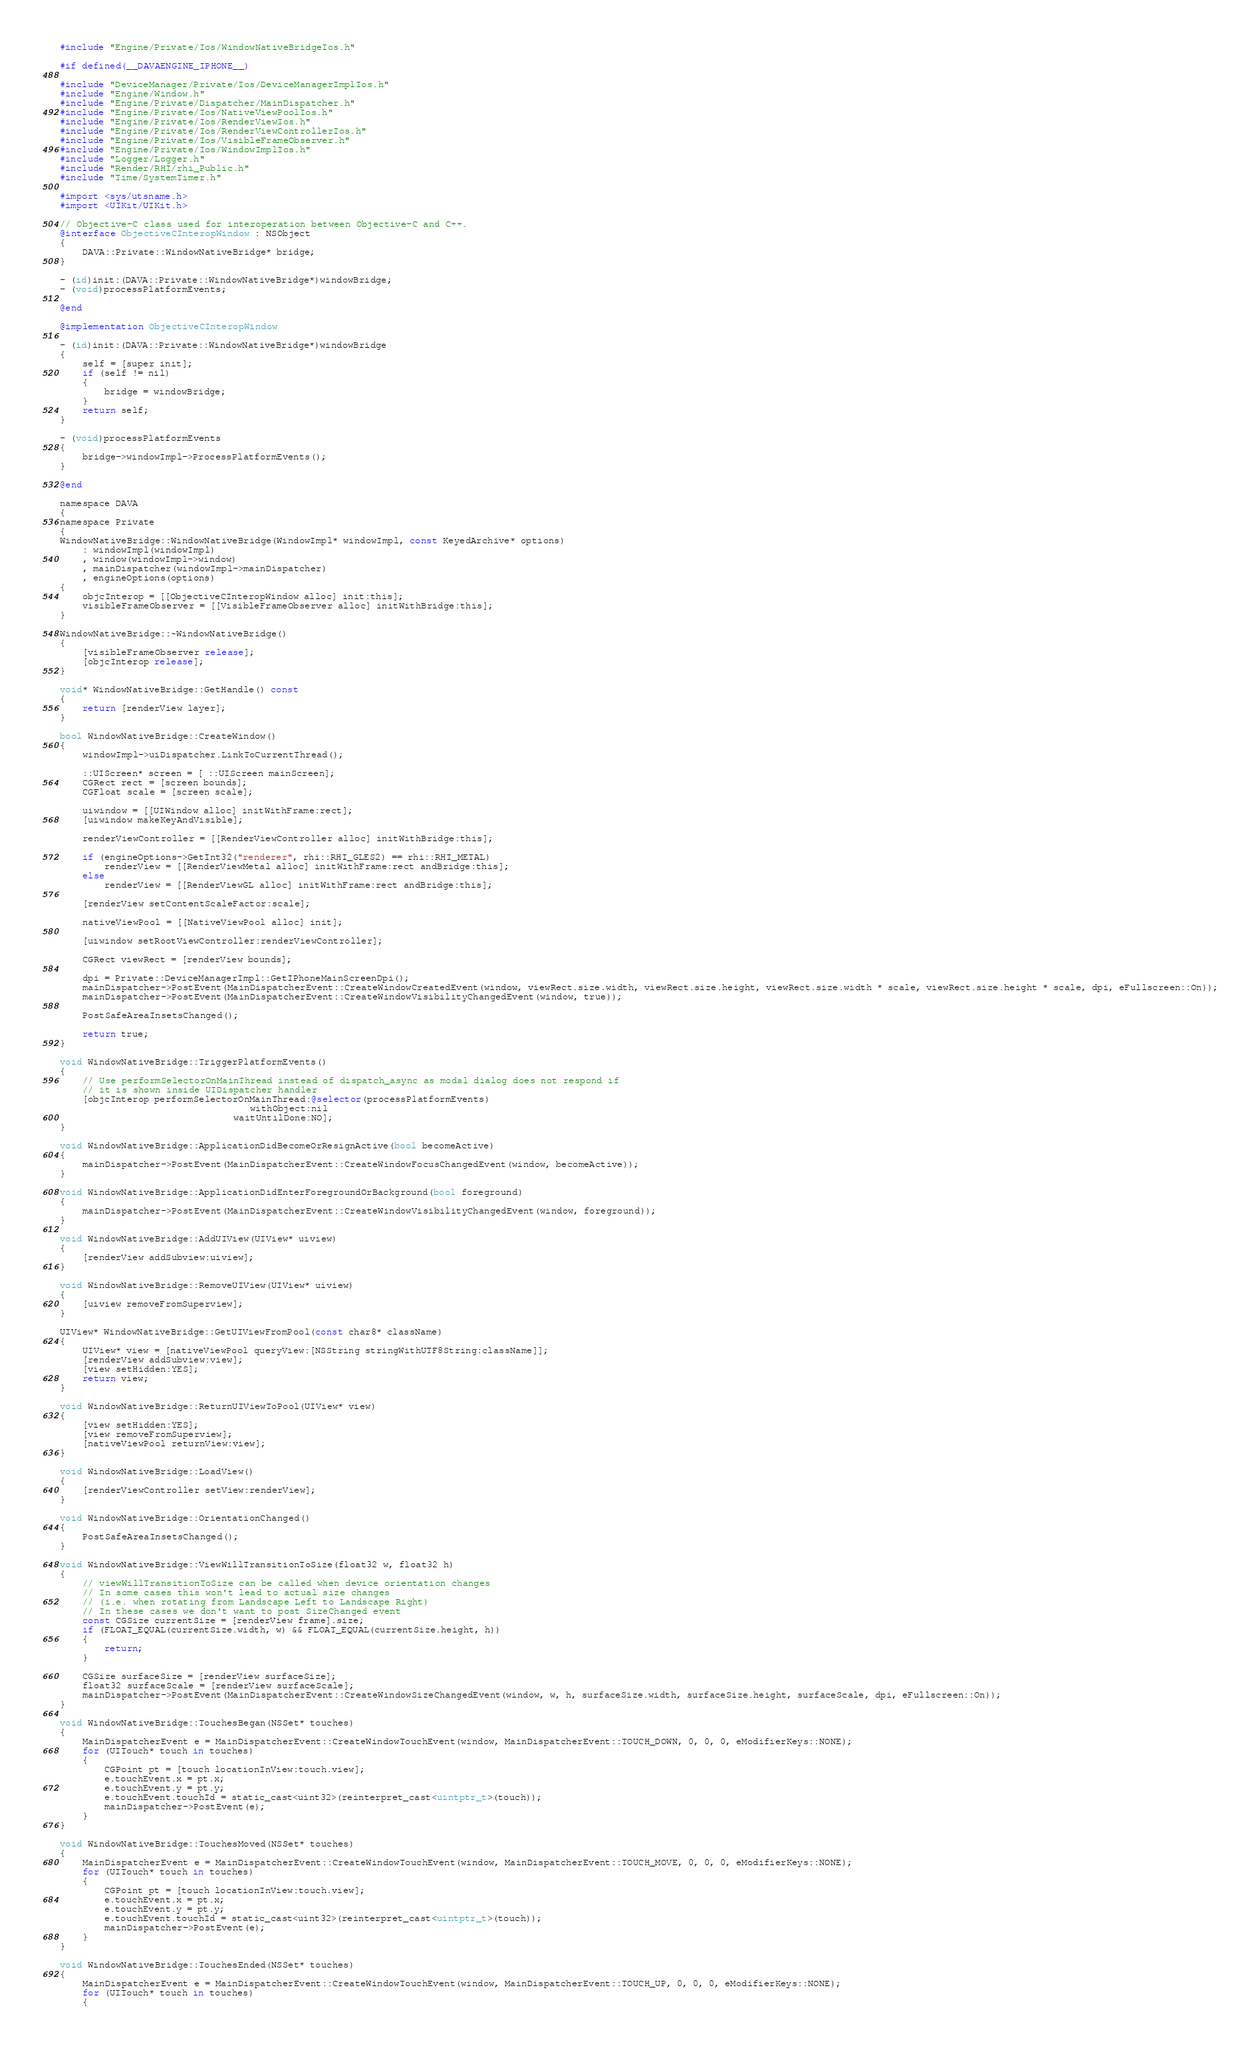<code> <loc_0><loc_0><loc_500><loc_500><_ObjectiveC_>#include "Engine/Private/Ios/WindowNativeBridgeIos.h"

#if defined(__DAVAENGINE_IPHONE__)

#include "DeviceManager/Private/Ios/DeviceManagerImplIos.h"
#include "Engine/Window.h"
#include "Engine/Private/Dispatcher/MainDispatcher.h"
#include "Engine/Private/Ios/NativeViewPoolIos.h"
#include "Engine/Private/Ios/RenderViewIos.h"
#include "Engine/Private/Ios/RenderViewControllerIos.h"
#include "Engine/Private/Ios/VisibleFrameObserver.h"
#include "Engine/Private/Ios/WindowImplIos.h"
#include "Logger/Logger.h"
#include "Render/RHI/rhi_Public.h"
#include "Time/SystemTimer.h"

#import <sys/utsname.h>
#import <UIKit/UIKit.h>

// Objective-C class used for interoperation between Objective-C and C++.
@interface ObjectiveCInteropWindow : NSObject
{
    DAVA::Private::WindowNativeBridge* bridge;
}

- (id)init:(DAVA::Private::WindowNativeBridge*)windowBridge;
- (void)processPlatformEvents;

@end

@implementation ObjectiveCInteropWindow

- (id)init:(DAVA::Private::WindowNativeBridge*)windowBridge
{
    self = [super init];
    if (self != nil)
    {
        bridge = windowBridge;
    }
    return self;
}

- (void)processPlatformEvents
{
    bridge->windowImpl->ProcessPlatformEvents();
}

@end

namespace DAVA
{
namespace Private
{
WindowNativeBridge::WindowNativeBridge(WindowImpl* windowImpl, const KeyedArchive* options)
    : windowImpl(windowImpl)
    , window(windowImpl->window)
    , mainDispatcher(windowImpl->mainDispatcher)
    , engineOptions(options)
{
    objcInterop = [[ObjectiveCInteropWindow alloc] init:this];
    visibleFrameObserver = [[VisibleFrameObserver alloc] initWithBridge:this];
}

WindowNativeBridge::~WindowNativeBridge()
{
    [visibleFrameObserver release];
    [objcInterop release];
}

void* WindowNativeBridge::GetHandle() const
{
    return [renderView layer];
}

bool WindowNativeBridge::CreateWindow()
{
    windowImpl->uiDispatcher.LinkToCurrentThread();

    ::UIScreen* screen = [ ::UIScreen mainScreen];
    CGRect rect = [screen bounds];
    CGFloat scale = [screen scale];

    uiwindow = [[UIWindow alloc] initWithFrame:rect];
    [uiwindow makeKeyAndVisible];

    renderViewController = [[RenderViewController alloc] initWithBridge:this];

    if (engineOptions->GetInt32("renderer", rhi::RHI_GLES2) == rhi::RHI_METAL)
        renderView = [[RenderViewMetal alloc] initWithFrame:rect andBridge:this];
    else
        renderView = [[RenderViewGL alloc] initWithFrame:rect andBridge:this];

    [renderView setContentScaleFactor:scale];

    nativeViewPool = [[NativeViewPool alloc] init];

    [uiwindow setRootViewController:renderViewController];

    CGRect viewRect = [renderView bounds];

    dpi = Private::DeviceManagerImpl::GetIPhoneMainScreenDpi();
    mainDispatcher->PostEvent(MainDispatcherEvent::CreateWindowCreatedEvent(window, viewRect.size.width, viewRect.size.height, viewRect.size.width * scale, viewRect.size.height * scale, dpi, eFullscreen::On));
    mainDispatcher->PostEvent(MainDispatcherEvent::CreateWindowVisibilityChangedEvent(window, true));

    PostSafeAreaInsetsChanged();

    return true;
}

void WindowNativeBridge::TriggerPlatformEvents()
{
    // Use performSelectorOnMainThread instead of dispatch_async as modal dialog does not respond if
    // it is shown inside UIDispatcher handler
    [objcInterop performSelectorOnMainThread:@selector(processPlatformEvents)
                                  withObject:nil
                               waitUntilDone:NO];
}

void WindowNativeBridge::ApplicationDidBecomeOrResignActive(bool becomeActive)
{
    mainDispatcher->PostEvent(MainDispatcherEvent::CreateWindowFocusChangedEvent(window, becomeActive));
}

void WindowNativeBridge::ApplicationDidEnterForegroundOrBackground(bool foreground)
{
    mainDispatcher->PostEvent(MainDispatcherEvent::CreateWindowVisibilityChangedEvent(window, foreground));
}

void WindowNativeBridge::AddUIView(UIView* uiview)
{
    [renderView addSubview:uiview];
}

void WindowNativeBridge::RemoveUIView(UIView* uiview)
{
    [uiview removeFromSuperview];
}

UIView* WindowNativeBridge::GetUIViewFromPool(const char8* className)
{
    UIView* view = [nativeViewPool queryView:[NSString stringWithUTF8String:className]];
    [renderView addSubview:view];
    [view setHidden:YES];
    return view;
}

void WindowNativeBridge::ReturnUIViewToPool(UIView* view)
{
    [view setHidden:YES];
    [view removeFromSuperview];
    [nativeViewPool returnView:view];
}

void WindowNativeBridge::LoadView()
{
    [renderViewController setView:renderView];
}

void WindowNativeBridge::OrientationChanged()
{
    PostSafeAreaInsetsChanged();
}

void WindowNativeBridge::ViewWillTransitionToSize(float32 w, float32 h)
{
    // viewWillTransitionToSize can be called when device orientation changes
    // In some cases this won't lead to actual size changes
    // (i.e. when rotating from Landscape Left to Landscape Right)
    // In these cases we don't want to post SizeChanged event
    const CGSize currentSize = [renderView frame].size;
    if (FLOAT_EQUAL(currentSize.width, w) && FLOAT_EQUAL(currentSize.height, h))
    {
        return;
    }

    CGSize surfaceSize = [renderView surfaceSize];
    float32 surfaceScale = [renderView surfaceScale];
    mainDispatcher->PostEvent(MainDispatcherEvent::CreateWindowSizeChangedEvent(window, w, h, surfaceSize.width, surfaceSize.height, surfaceScale, dpi, eFullscreen::On));
}

void WindowNativeBridge::TouchesBegan(NSSet* touches)
{
    MainDispatcherEvent e = MainDispatcherEvent::CreateWindowTouchEvent(window, MainDispatcherEvent::TOUCH_DOWN, 0, 0, 0, eModifierKeys::NONE);
    for (UITouch* touch in touches)
    {
        CGPoint pt = [touch locationInView:touch.view];
        e.touchEvent.x = pt.x;
        e.touchEvent.y = pt.y;
        e.touchEvent.touchId = static_cast<uint32>(reinterpret_cast<uintptr_t>(touch));
        mainDispatcher->PostEvent(e);
    }
}

void WindowNativeBridge::TouchesMoved(NSSet* touches)
{
    MainDispatcherEvent e = MainDispatcherEvent::CreateWindowTouchEvent(window, MainDispatcherEvent::TOUCH_MOVE, 0, 0, 0, eModifierKeys::NONE);
    for (UITouch* touch in touches)
    {
        CGPoint pt = [touch locationInView:touch.view];
        e.touchEvent.x = pt.x;
        e.touchEvent.y = pt.y;
        e.touchEvent.touchId = static_cast<uint32>(reinterpret_cast<uintptr_t>(touch));
        mainDispatcher->PostEvent(e);
    }
}

void WindowNativeBridge::TouchesEnded(NSSet* touches)
{
    MainDispatcherEvent e = MainDispatcherEvent::CreateWindowTouchEvent(window, MainDispatcherEvent::TOUCH_UP, 0, 0, 0, eModifierKeys::NONE);
    for (UITouch* touch in touches)
    {</code> 